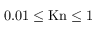<formula> <loc_0><loc_0><loc_500><loc_500>0 . 0 1 \leq K n \leq 1</formula> 